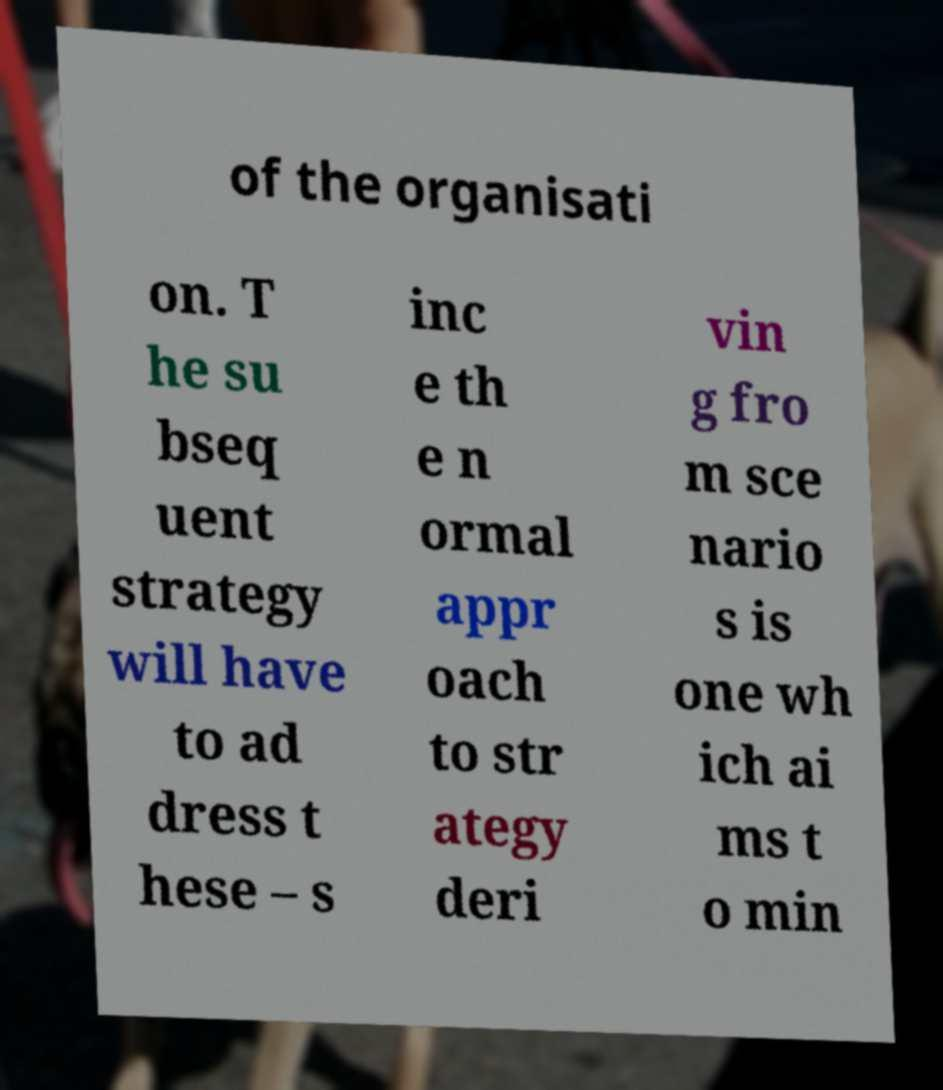For documentation purposes, I need the text within this image transcribed. Could you provide that? of the organisati on. T he su bseq uent strategy will have to ad dress t hese – s inc e th e n ormal appr oach to str ategy deri vin g fro m sce nario s is one wh ich ai ms t o min 